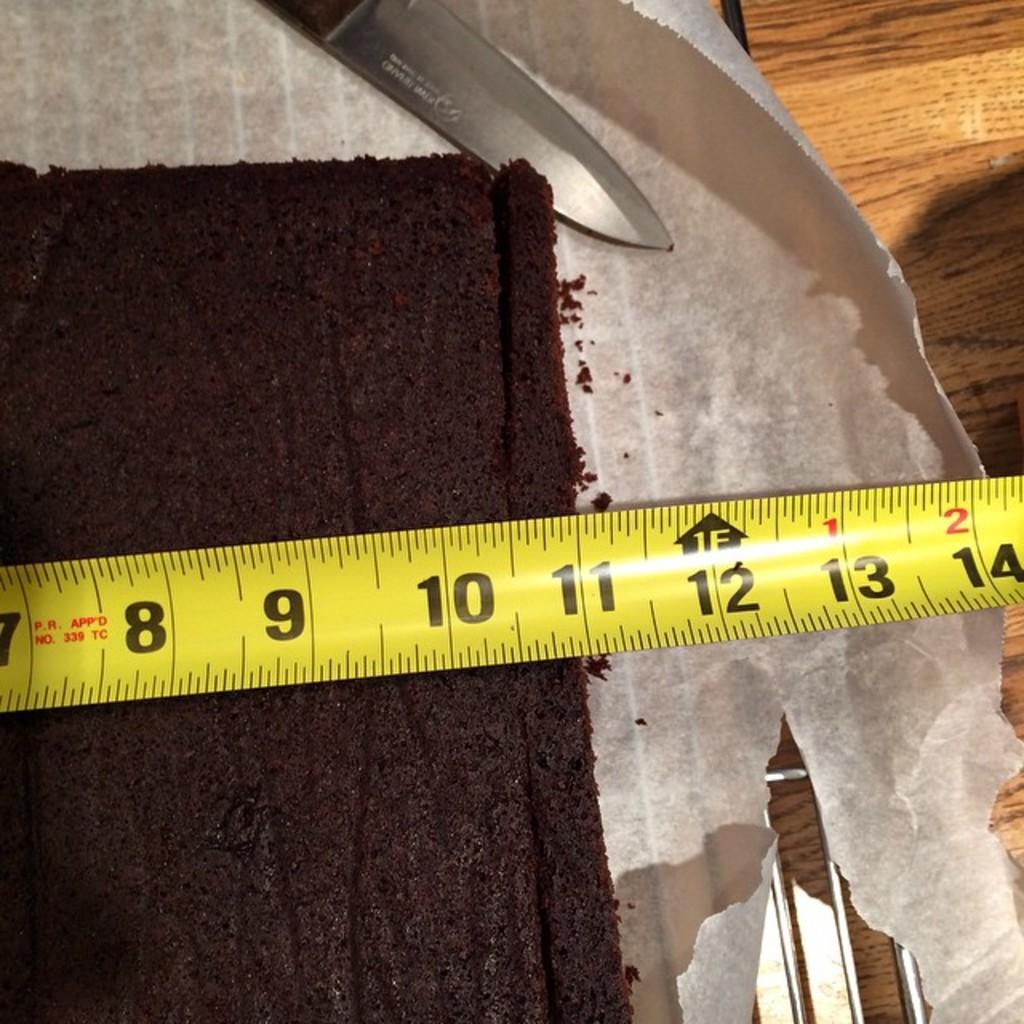How long is it?
Provide a short and direct response. 11 inches. 